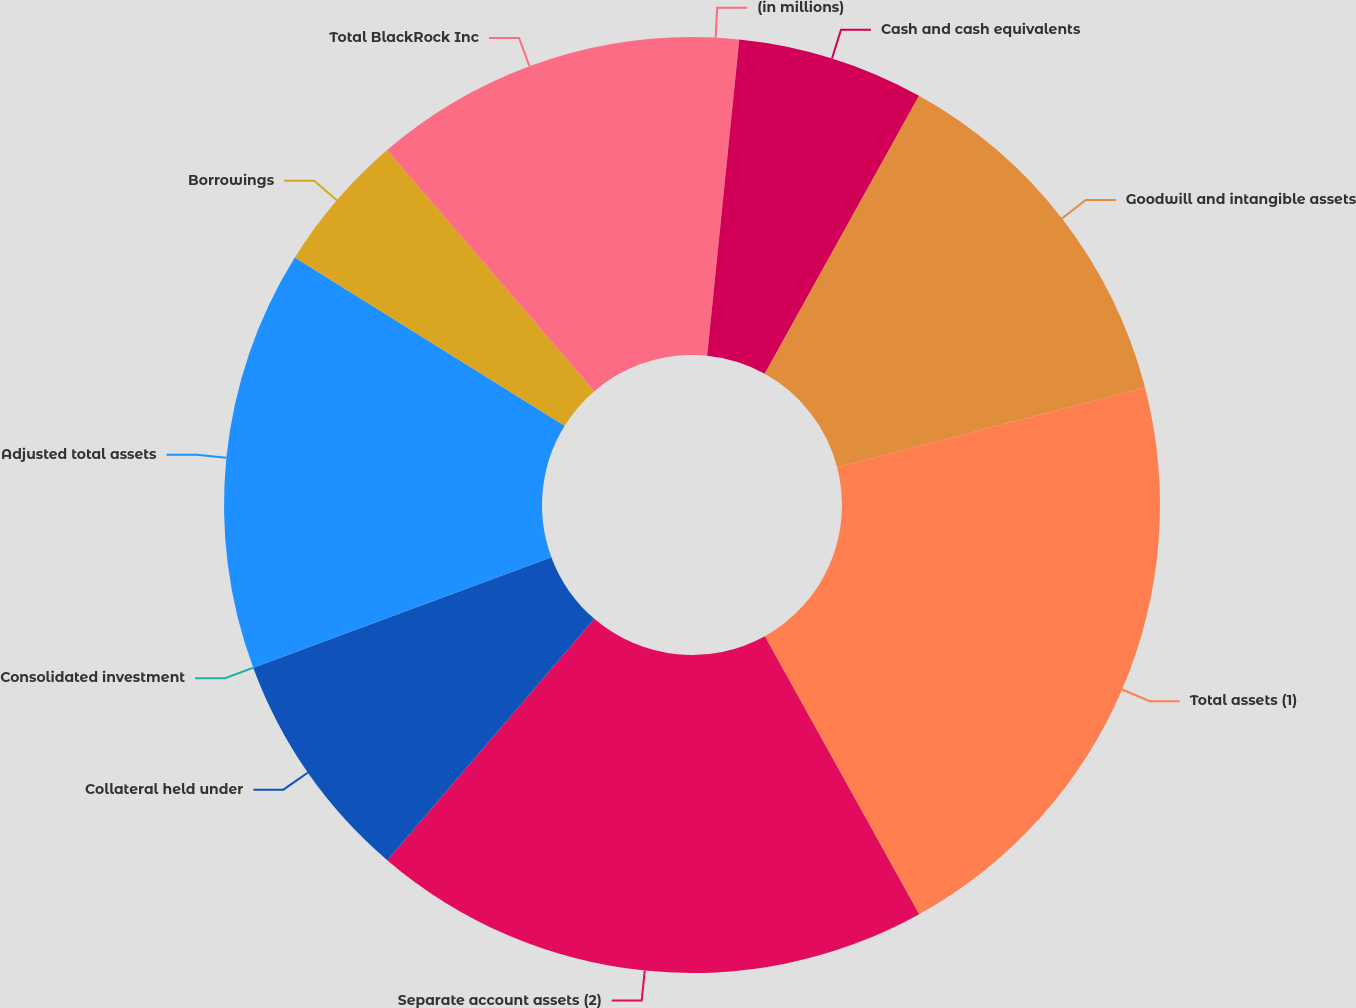Convert chart. <chart><loc_0><loc_0><loc_500><loc_500><pie_chart><fcel>(in millions)<fcel>Cash and cash equivalents<fcel>Goodwill and intangible assets<fcel>Total assets (1)<fcel>Separate account assets (2)<fcel>Collateral held under<fcel>Consolidated investment<fcel>Adjusted total assets<fcel>Borrowings<fcel>Total BlackRock Inc<nl><fcel>1.61%<fcel>6.45%<fcel>12.9%<fcel>20.97%<fcel>19.35%<fcel>8.06%<fcel>0.0%<fcel>14.52%<fcel>4.84%<fcel>11.29%<nl></chart> 